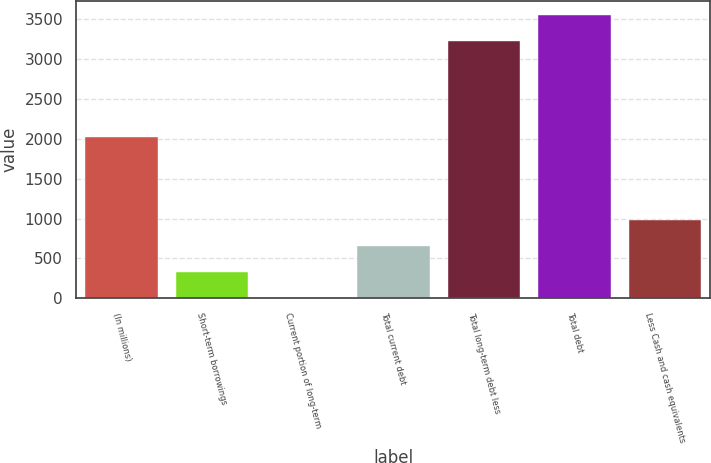<chart> <loc_0><loc_0><loc_500><loc_500><bar_chart><fcel>(In millions)<fcel>Short-term borrowings<fcel>Current portion of long-term<fcel>Total current debt<fcel>Total long-term debt less<fcel>Total debt<fcel>Less Cash and cash equivalents<nl><fcel>2017<fcel>327.78<fcel>2.2<fcel>653.36<fcel>3230.5<fcel>3556.08<fcel>978.94<nl></chart> 